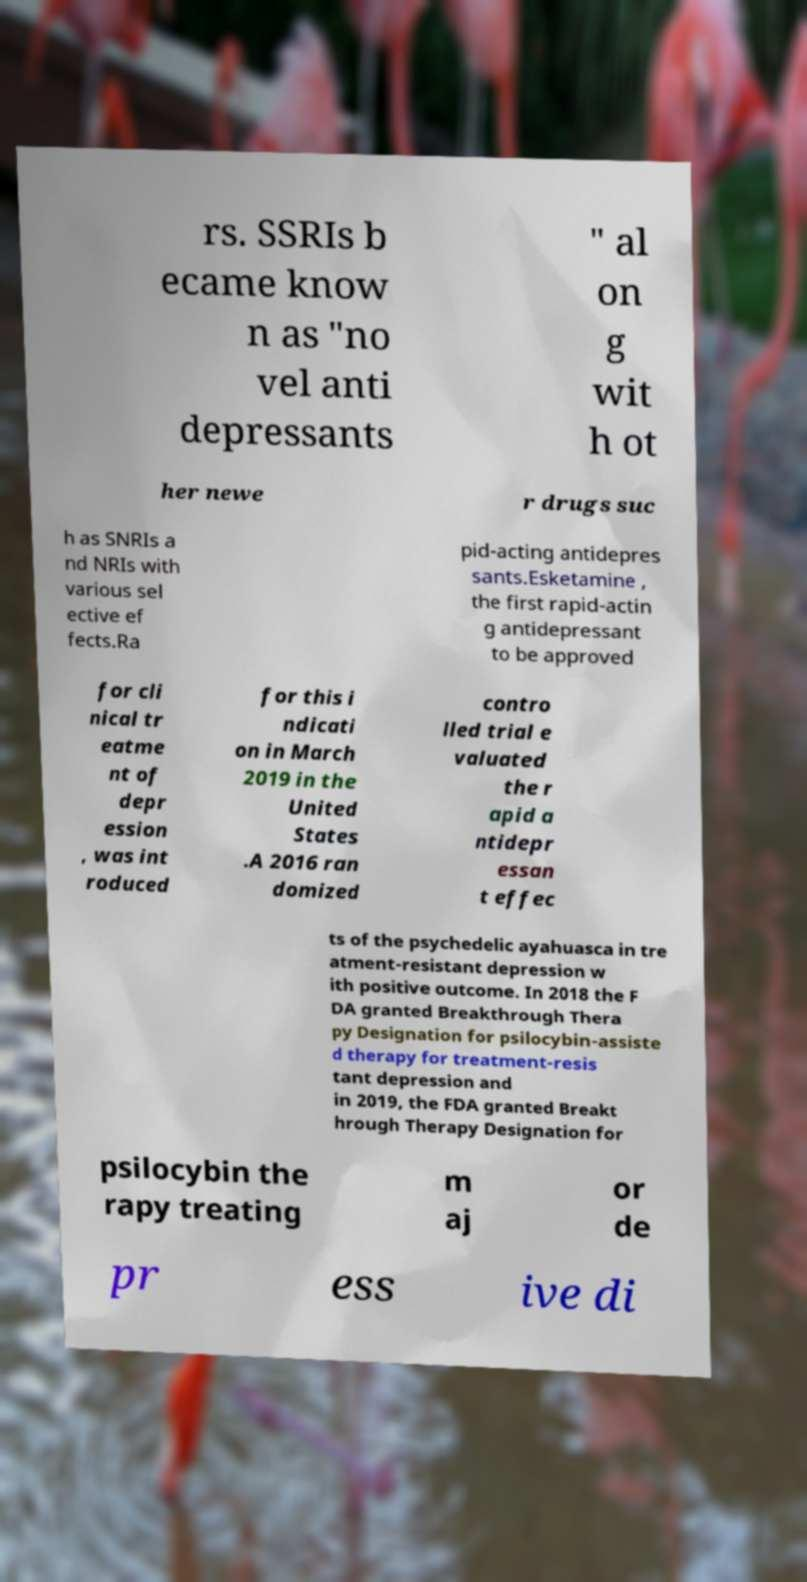Could you extract and type out the text from this image? rs. SSRIs b ecame know n as "no vel anti depressants " al on g wit h ot her newe r drugs suc h as SNRIs a nd NRIs with various sel ective ef fects.Ra pid-acting antidepres sants.Esketamine , the first rapid-actin g antidepressant to be approved for cli nical tr eatme nt of depr ession , was int roduced for this i ndicati on in March 2019 in the United States .A 2016 ran domized contro lled trial e valuated the r apid a ntidepr essan t effec ts of the psychedelic ayahuasca in tre atment-resistant depression w ith positive outcome. In 2018 the F DA granted Breakthrough Thera py Designation for psilocybin-assiste d therapy for treatment-resis tant depression and in 2019, the FDA granted Breakt hrough Therapy Designation for psilocybin the rapy treating m aj or de pr ess ive di 